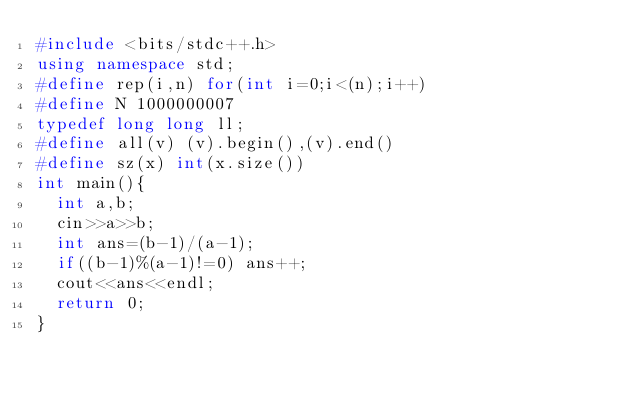Convert code to text. <code><loc_0><loc_0><loc_500><loc_500><_C++_>#include <bits/stdc++.h>
using namespace std;
#define rep(i,n) for(int i=0;i<(n);i++)
#define N 1000000007
typedef long long ll;
#define all(v) (v).begin(),(v).end()
#define sz(x) int(x.size())
int main(){
	int a,b;
	cin>>a>>b;
	int ans=(b-1)/(a-1);
	if((b-1)%(a-1)!=0) ans++;
	cout<<ans<<endl;
	return 0;
}</code> 